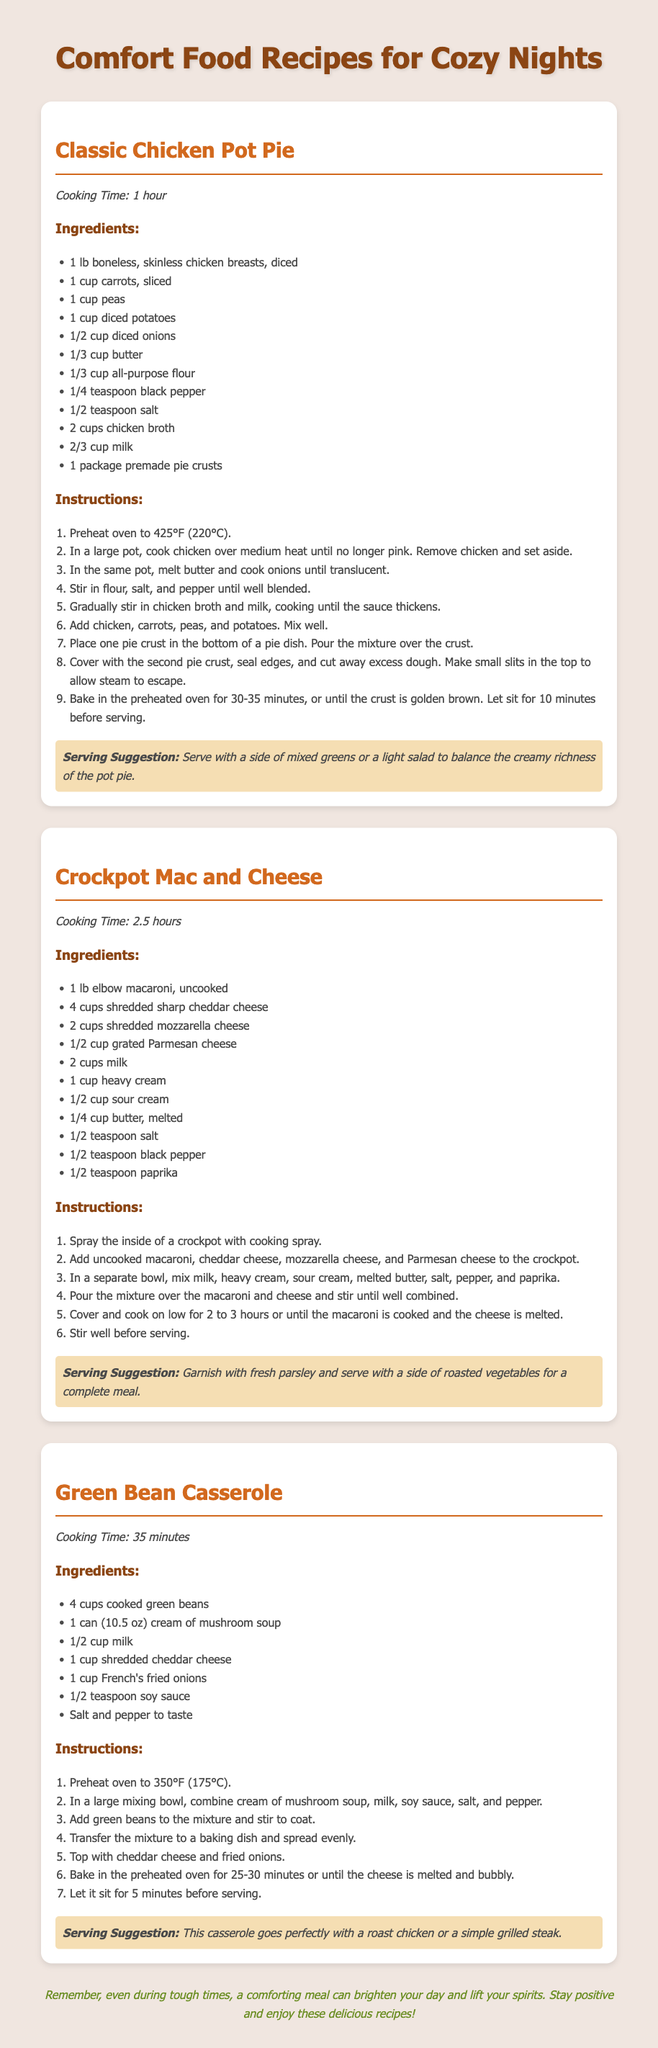What is the title of the first recipe? The first recipe's title is "Classic Chicken Pot Pie."
Answer: Classic Chicken Pot Pie How long does it take to cook the Crockpot Mac and Cheese? The cooking time for Crockpot Mac and Cheese is 2.5 hours.
Answer: 2.5 hours What type of cheese is used in the Green Bean Casserole? The Green Bean Casserole uses shredded cheddar cheese.
Answer: shredded cheddar cheese What is one suggested garnish for the Crockpot Mac and Cheese? A suggested garnish for the Crockpot Mac and Cheese is fresh parsley.
Answer: fresh parsley How many minutes should the Classic Chicken Pot Pie sit before serving? The Classic Chicken Pot Pie should sit for 10 minutes before serving.
Answer: 10 minutes What ingredient is used to coat the chicken in the Classic Chicken Pot Pie? The chicken is coated with a mixture of chicken broth and milk.
Answer: chicken broth and milk How many servings does the document suggest for each recipe? The document does not specify the number of servings for each recipe.
Answer: Not specified What type of meal does the document suggest pairing with the Green Bean Casserole? The document suggests pairing the Green Bean Casserole with a roast chicken or a simple grilled steak.
Answer: roast chicken or simple grilled steak What style of food is the document focused on? The document focuses on comfort food recipes.
Answer: comfort food recipes 